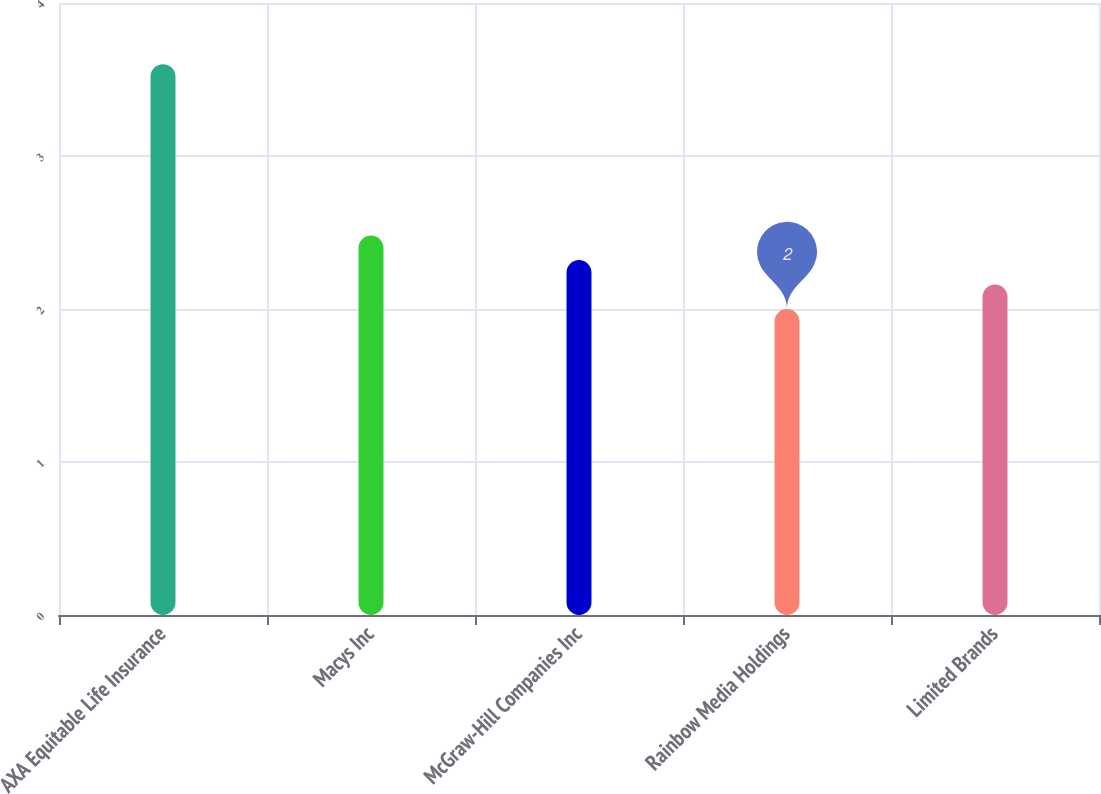<chart> <loc_0><loc_0><loc_500><loc_500><bar_chart><fcel>AXA Equitable Life Insurance<fcel>Macys Inc<fcel>McGraw-Hill Companies Inc<fcel>Rainbow Media Holdings<fcel>Limited Brands<nl><fcel>3.6<fcel>2.48<fcel>2.32<fcel>2<fcel>2.16<nl></chart> 